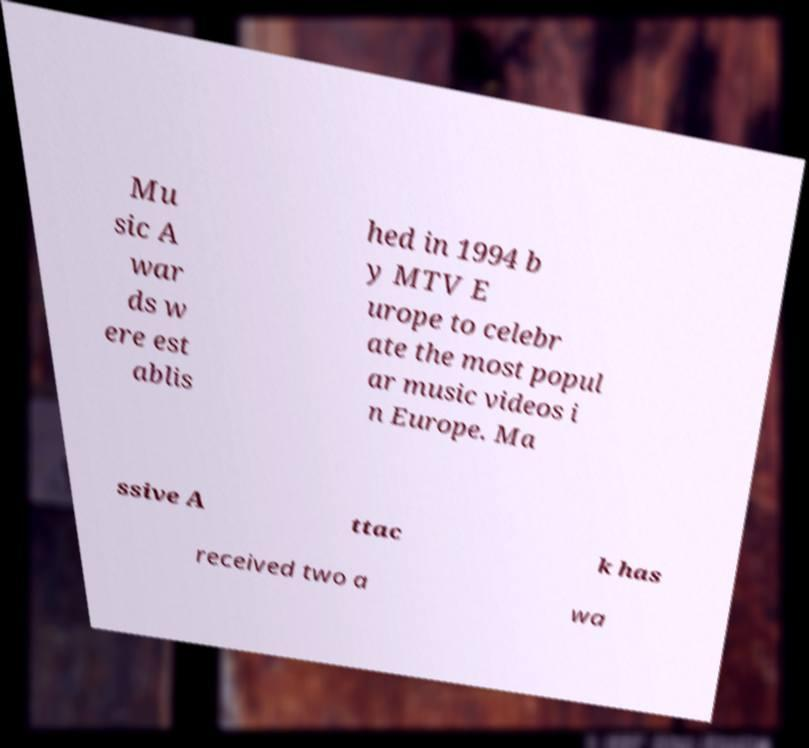I need the written content from this picture converted into text. Can you do that? Mu sic A war ds w ere est ablis hed in 1994 b y MTV E urope to celebr ate the most popul ar music videos i n Europe. Ma ssive A ttac k has received two a wa 